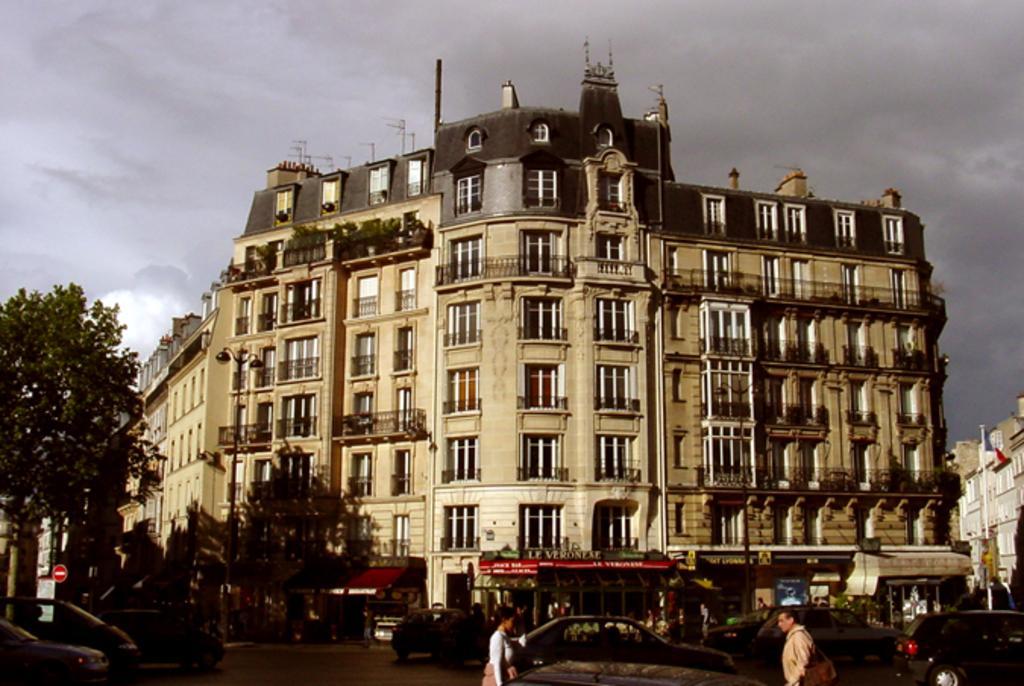Could you give a brief overview of what you see in this image? In the center of the image there is a building. There are stores. At the bottom of the image there is road on which there vehicles and people walking. There are trees to the left side of the image. In the background of the image there are sky and clouds. 